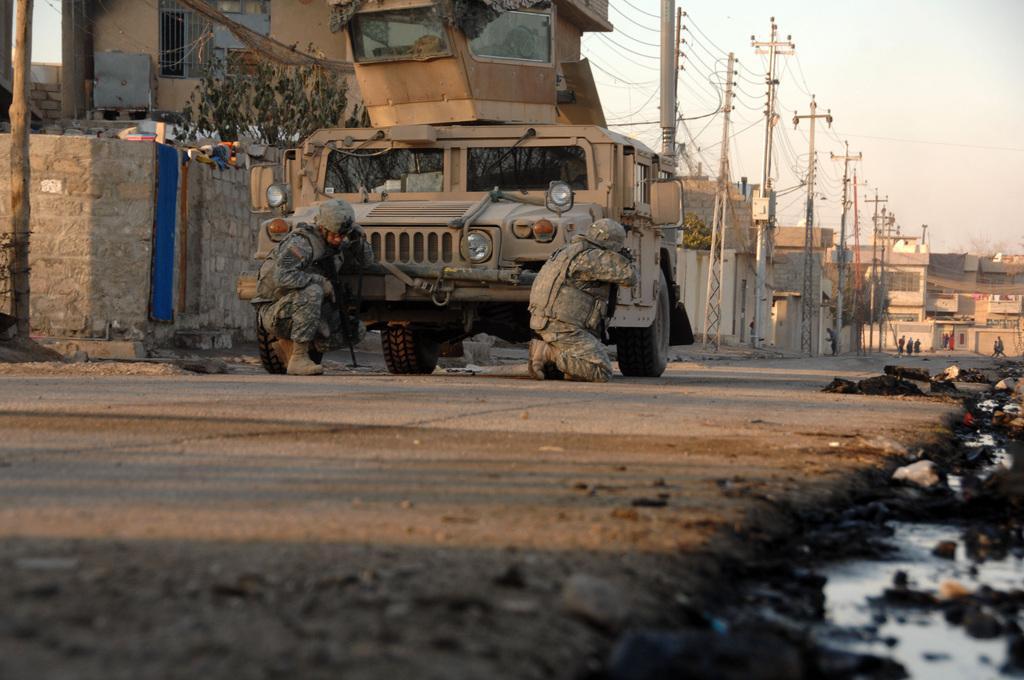In one or two sentences, can you explain what this image depicts? In this image we can see two persons in on the road at the vehicle and holding guns in their hands. In the background we can see buildings, few persons, trees, doors, windows, poles, electric wires, wastage on the ground, objects and water. 